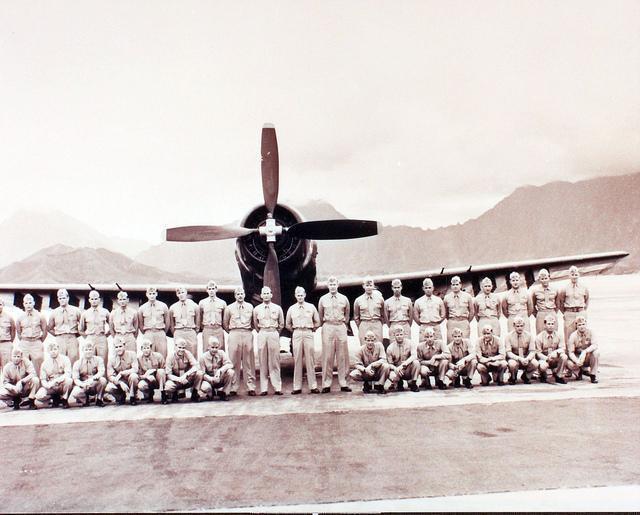How many people are there?
Give a very brief answer. 4. 